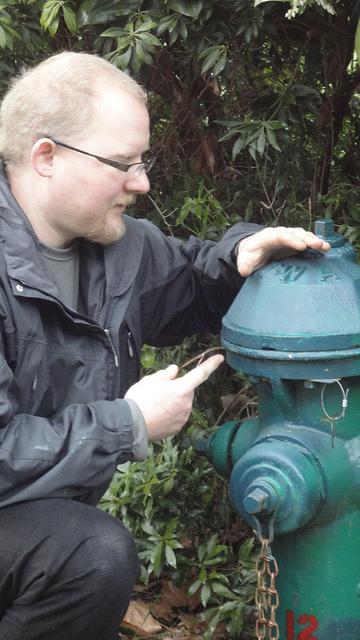Is this man wearing glasses?
Answer briefly. Yes. What is the purpose of the chain on the green object?
Be succinct. To keep cap from being removed. What color is the hydrant?
Concise answer only. Green. 